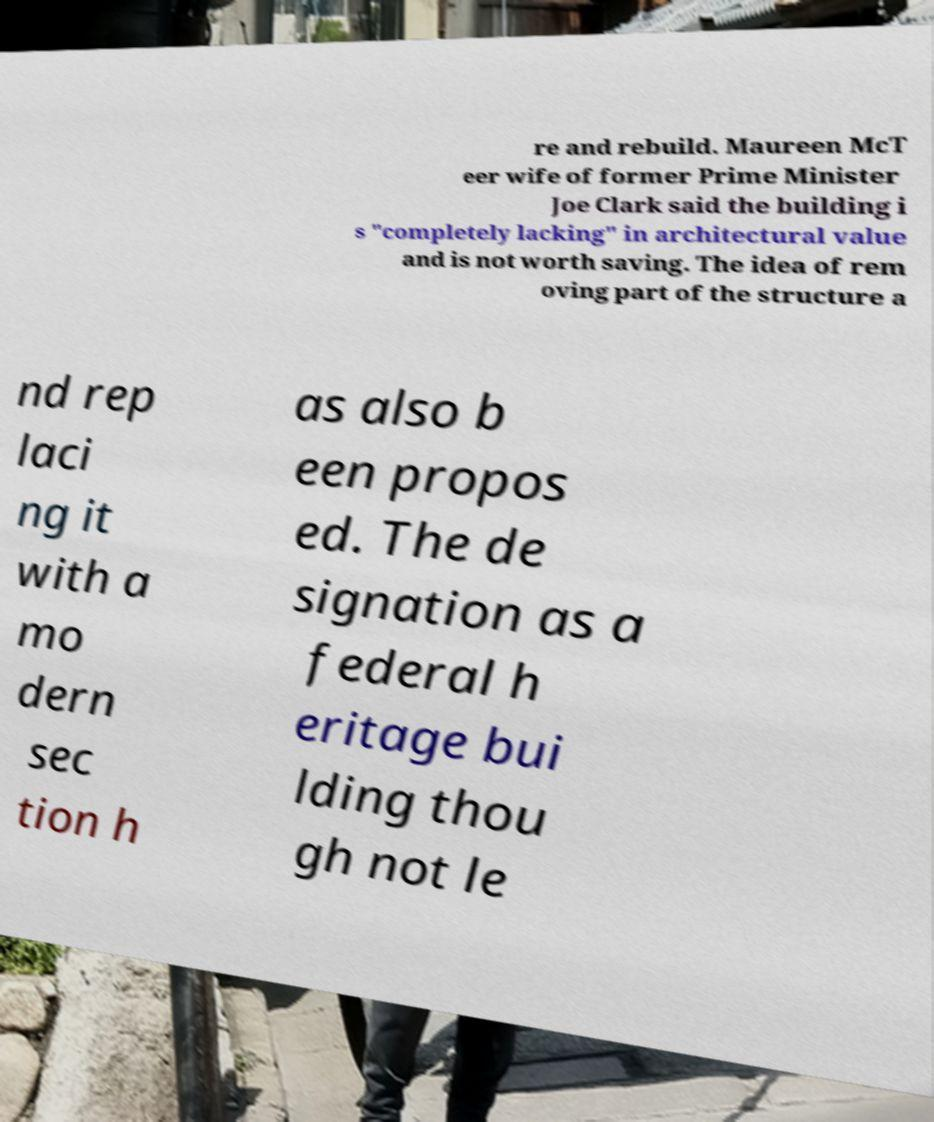Can you read and provide the text displayed in the image?This photo seems to have some interesting text. Can you extract and type it out for me? re and rebuild. Maureen McT eer wife of former Prime Minister Joe Clark said the building i s "completely lacking" in architectural value and is not worth saving. The idea of rem oving part of the structure a nd rep laci ng it with a mo dern sec tion h as also b een propos ed. The de signation as a federal h eritage bui lding thou gh not le 